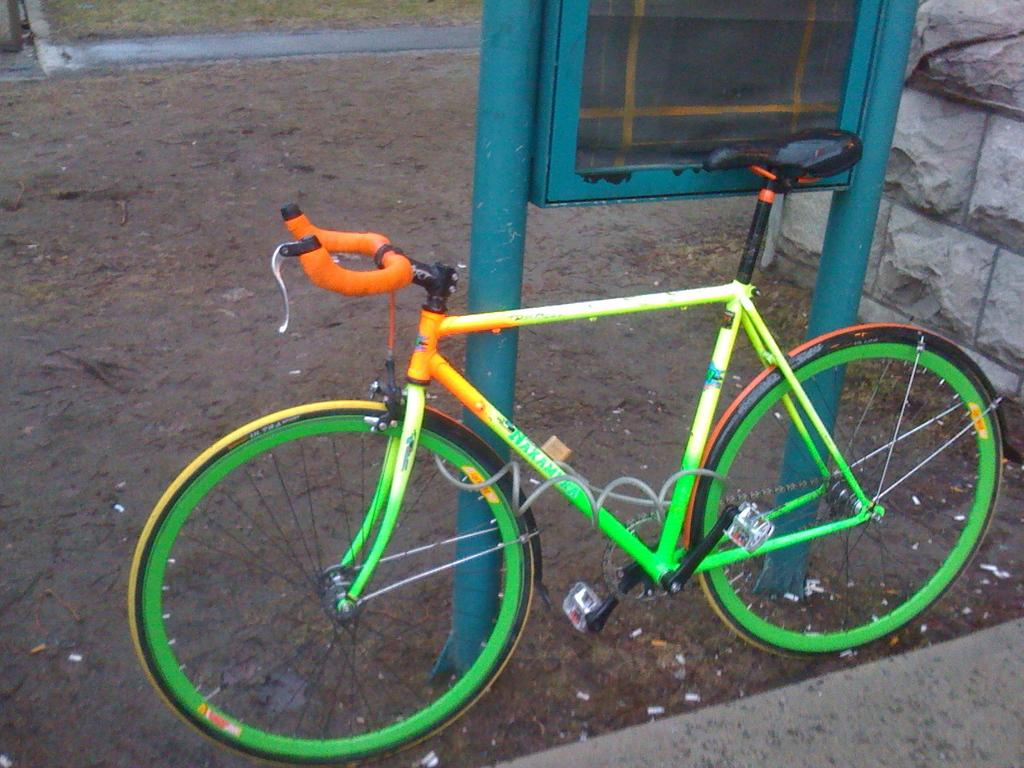What is the main object in the center of the image? There is a cycle in the center of the image. What can be seen in the background of the image? There is a board and a wall in the background of the image. What type of terrain is visible at the bottom of the image? There is sand and grass at the bottom of the image. What kind of path is present at the bottom of the image? There is a walkway at the bottom of the image. What type of chalk is being used to draw on the board in the image? There is no chalk visible in the image, and no drawing activity is taking place on the board. Can you tell me what the father of the person riding the cycle looks like in the image? There is no person riding the cycle in the image, and no individuals are depicted in the image. 